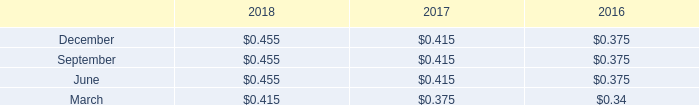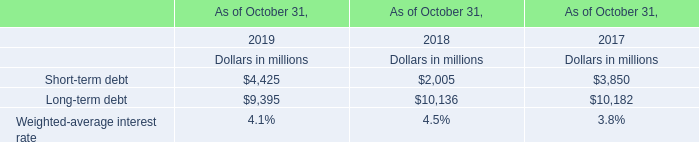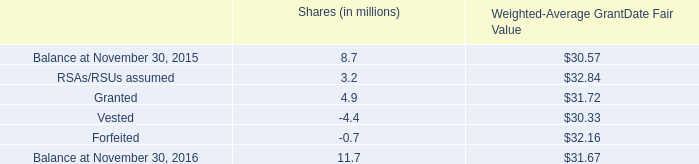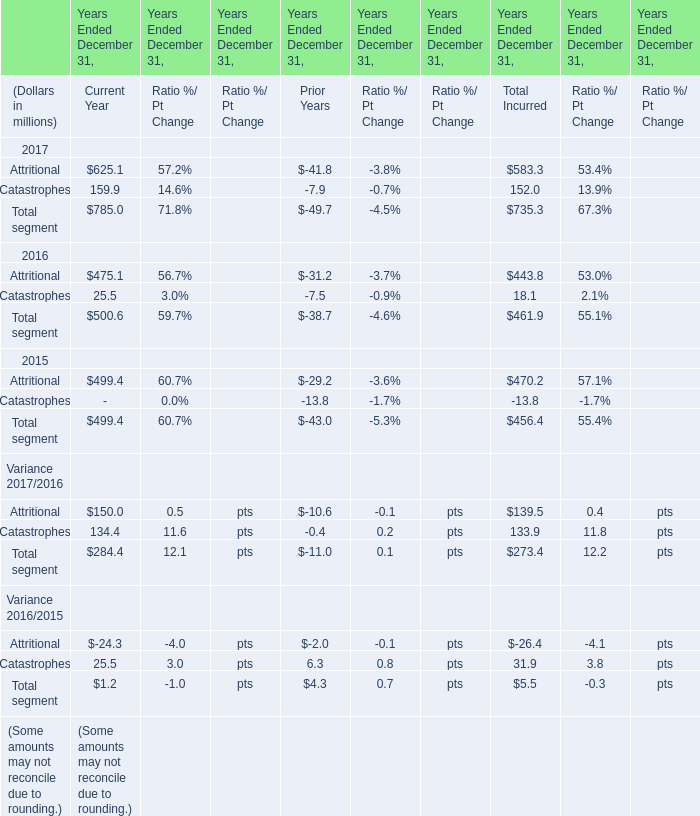When is Attritional the largest for Current Year ? 
Answer: 2017. 